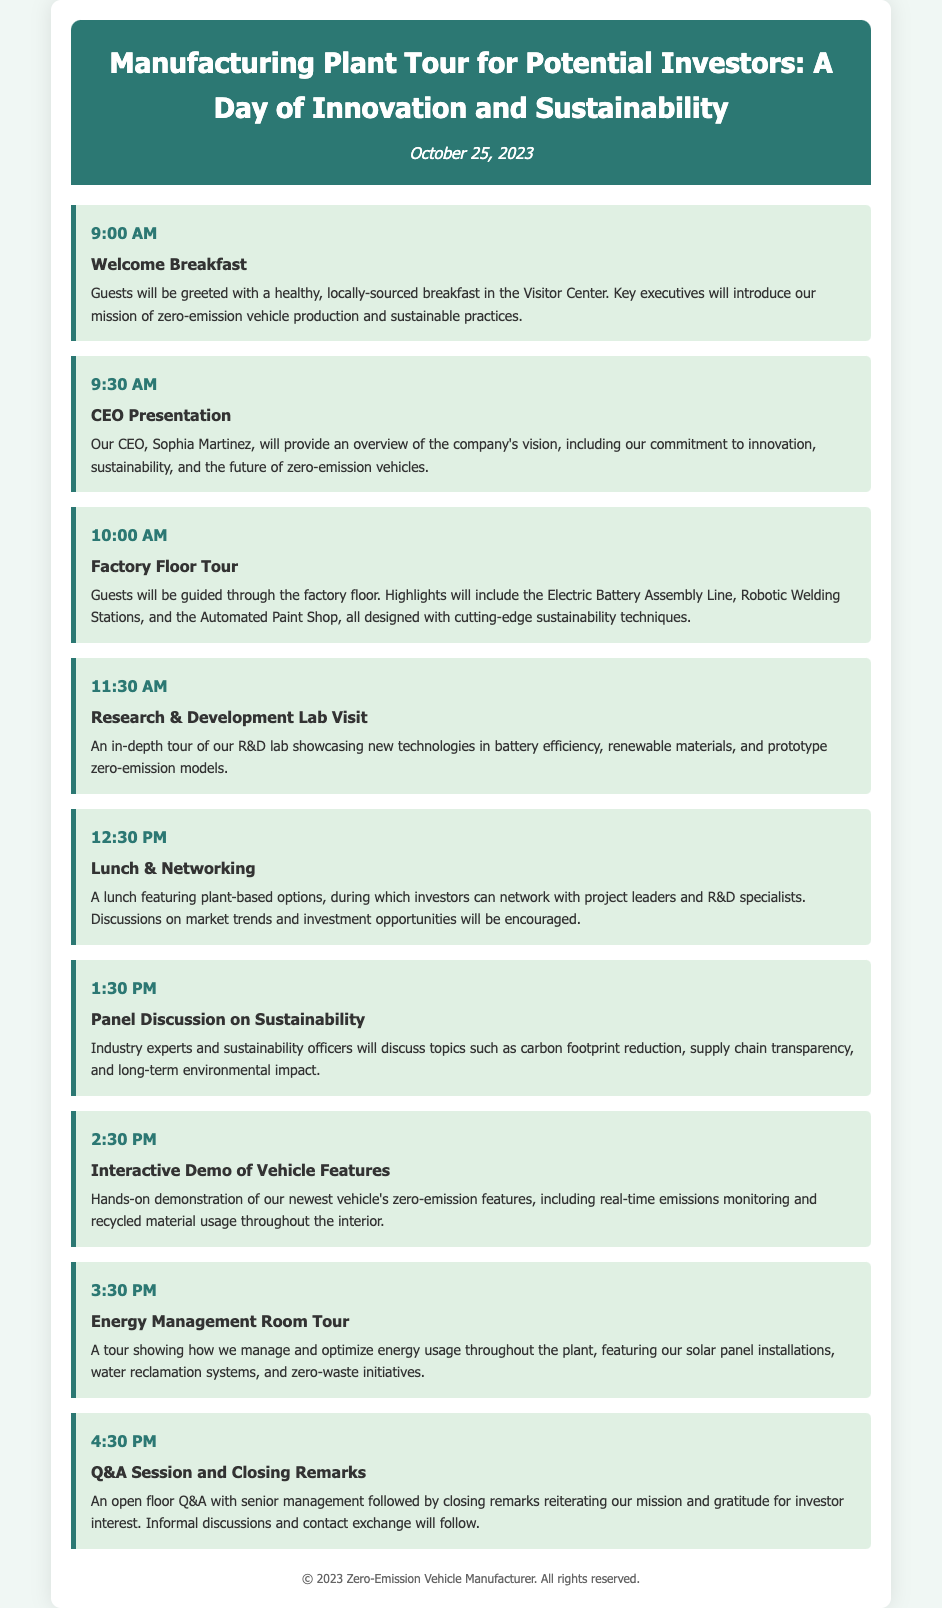What time does the welcome breakfast start? The welcome breakfast begins at 9:00 AM, as listed in the schedule.
Answer: 9:00 AM Who will give the CEO presentation? The document specifies that the presentation will be given by CEO Sophia Martinez.
Answer: Sophia Martinez What is featured during the factory floor tour? The tour highlights include the Electric Battery Assembly Line, Robotic Welding Stations, and the Automated Paint Shop.
Answer: Electric Battery Assembly Line, Robotic Welding Stations, Automated Paint Shop What is the purpose of the research & development lab visit? The visit is intended to showcase new technologies in battery efficiency, renewable materials, and prototype zero-emission models.
Answer: Showcasing new technologies How long is the panel discussion on sustainability scheduled for? The panel discussion is scheduled to start at 1:30 PM and continues for one hour until the next event at 2:30 PM.
Answer: One hour What type of lunch will be provided? The lunch will feature plant-based options for guests.
Answer: Plant-based options What is the focus of the Q&A session? The Q&A session allows for open questions with senior management and is followed by closing remarks.
Answer: Open questions with senior management What is a key aspect of the energy management room tour? The tour includes insights into how energy usage is managed and optimized throughout the plant.
Answer: Managing and optimizing energy usage 